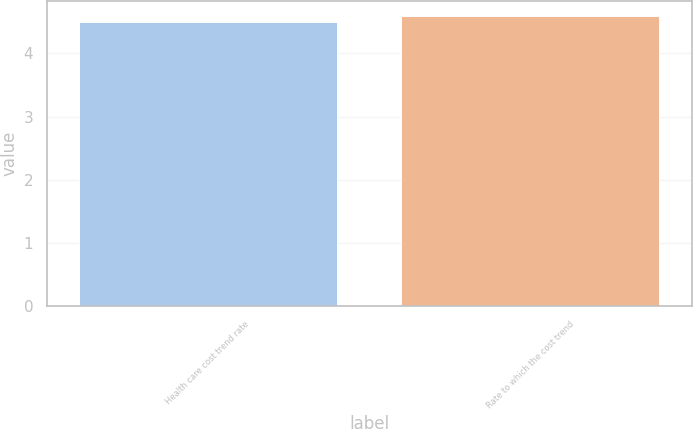Convert chart. <chart><loc_0><loc_0><loc_500><loc_500><bar_chart><fcel>Health care cost trend rate<fcel>Rate to which the cost trend<nl><fcel>4.5<fcel>4.6<nl></chart> 